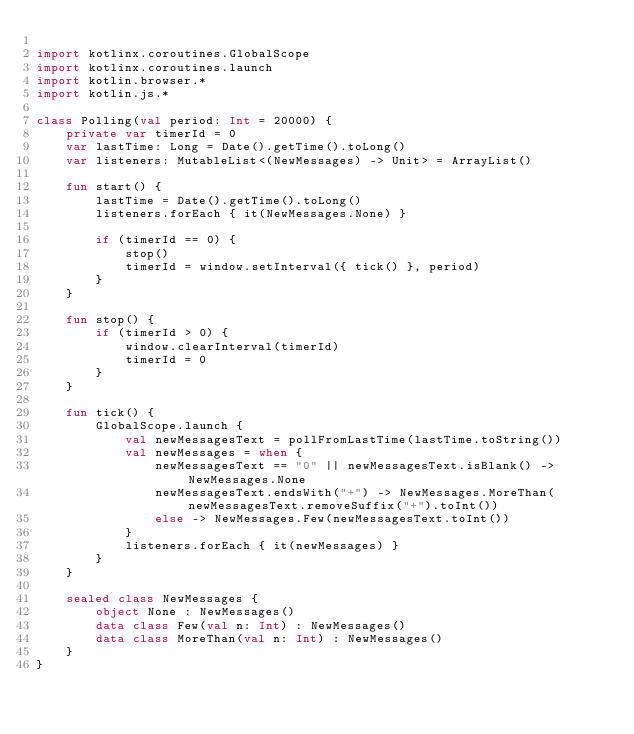Convert code to text. <code><loc_0><loc_0><loc_500><loc_500><_Kotlin_>
import kotlinx.coroutines.GlobalScope
import kotlinx.coroutines.launch
import kotlin.browser.*
import kotlin.js.*

class Polling(val period: Int = 20000) {
    private var timerId = 0
    var lastTime: Long = Date().getTime().toLong()
    var listeners: MutableList<(NewMessages) -> Unit> = ArrayList()

    fun start() {
        lastTime = Date().getTime().toLong()
        listeners.forEach { it(NewMessages.None) }

        if (timerId == 0) {
            stop()
            timerId = window.setInterval({ tick() }, period)
        }
    }

    fun stop() {
        if (timerId > 0) {
            window.clearInterval(timerId)
            timerId = 0
        }
    }

    fun tick() {
        GlobalScope.launch {
            val newMessagesText = pollFromLastTime(lastTime.toString())
            val newMessages = when {
                newMessagesText == "0" || newMessagesText.isBlank() -> NewMessages.None
                newMessagesText.endsWith("+") -> NewMessages.MoreThan(newMessagesText.removeSuffix("+").toInt())
                else -> NewMessages.Few(newMessagesText.toInt())
            }
            listeners.forEach { it(newMessages) }
        }
    }

    sealed class NewMessages {
        object None : NewMessages()
        data class Few(val n: Int) : NewMessages()
        data class MoreThan(val n: Int) : NewMessages()
    }
}
</code> 